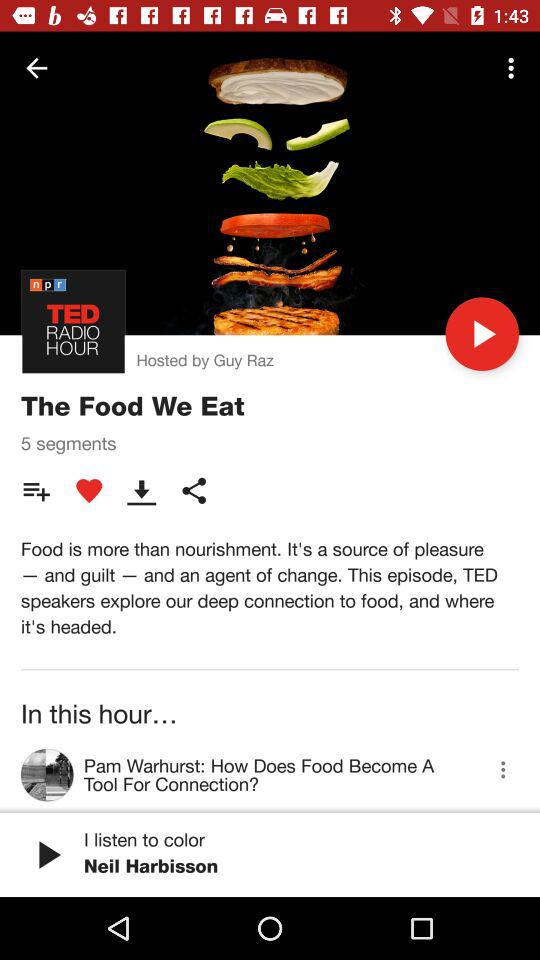Who is the host of the episode? The host of the episode is Guy Raz. 